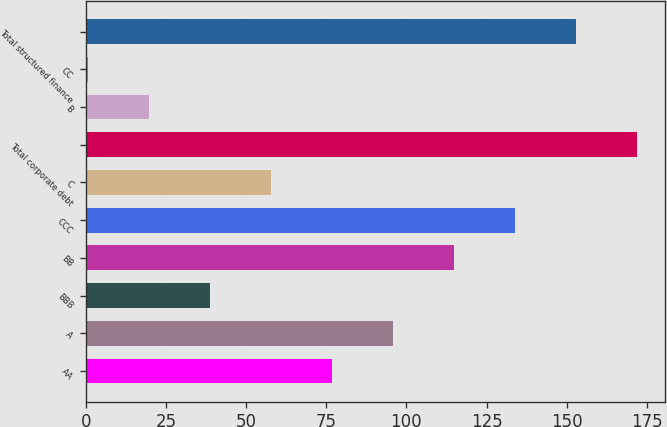Convert chart to OTSL. <chart><loc_0><loc_0><loc_500><loc_500><bar_chart><fcel>AA<fcel>A<fcel>BBB<fcel>BB<fcel>CCC<fcel>C<fcel>Total corporate debt<fcel>B<fcel>CC<fcel>Total structured finance<nl><fcel>76.92<fcel>95.95<fcel>38.86<fcel>114.98<fcel>134.01<fcel>57.89<fcel>172.07<fcel>19.83<fcel>0.8<fcel>153.04<nl></chart> 